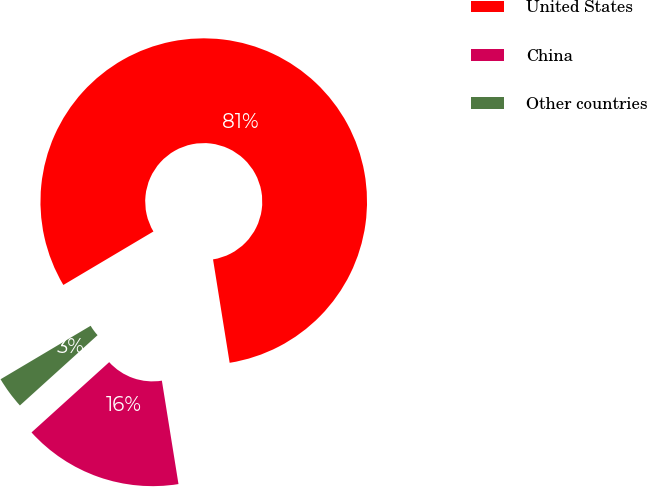<chart> <loc_0><loc_0><loc_500><loc_500><pie_chart><fcel>United States<fcel>China<fcel>Other countries<nl><fcel>80.99%<fcel>15.83%<fcel>3.18%<nl></chart> 